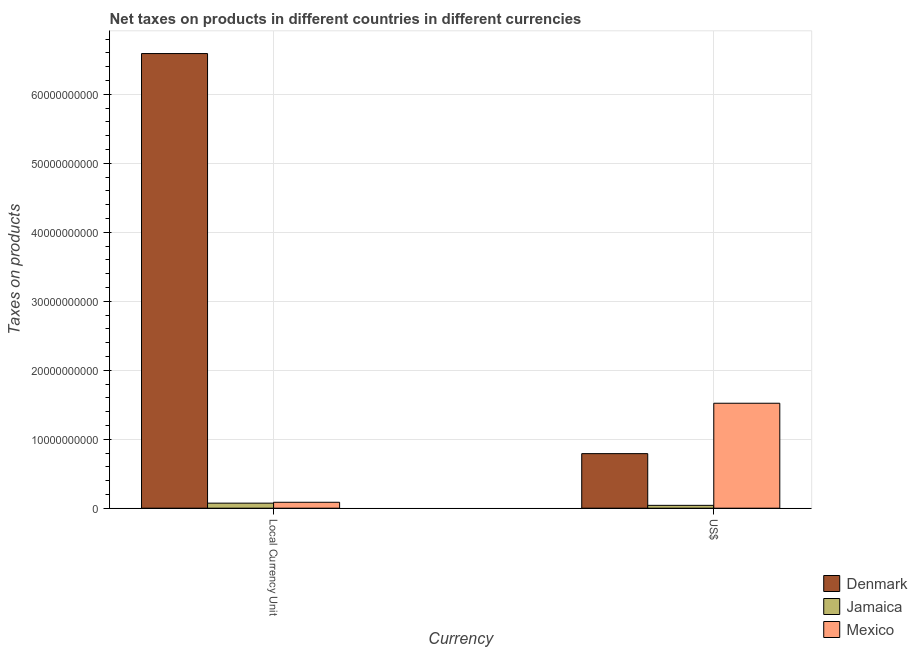How many groups of bars are there?
Your response must be concise. 2. Are the number of bars on each tick of the X-axis equal?
Make the answer very short. Yes. How many bars are there on the 1st tick from the right?
Make the answer very short. 3. What is the label of the 2nd group of bars from the left?
Provide a short and direct response. US$. What is the net taxes in constant 2005 us$ in Denmark?
Offer a terse response. 6.59e+1. Across all countries, what is the maximum net taxes in us$?
Your response must be concise. 1.52e+1. Across all countries, what is the minimum net taxes in us$?
Offer a terse response. 4.11e+08. In which country was the net taxes in constant 2005 us$ maximum?
Your answer should be very brief. Denmark. In which country was the net taxes in constant 2005 us$ minimum?
Give a very brief answer. Jamaica. What is the total net taxes in us$ in the graph?
Your answer should be compact. 2.35e+1. What is the difference between the net taxes in us$ in Denmark and that in Jamaica?
Keep it short and to the point. 7.50e+09. What is the difference between the net taxes in constant 2005 us$ in Mexico and the net taxes in us$ in Jamaica?
Provide a succinct answer. 4.47e+08. What is the average net taxes in us$ per country?
Your answer should be compact. 7.84e+09. What is the difference between the net taxes in constant 2005 us$ and net taxes in us$ in Mexico?
Provide a short and direct response. -1.44e+1. In how many countries, is the net taxes in constant 2005 us$ greater than 44000000000 units?
Your answer should be compact. 1. What is the ratio of the net taxes in us$ in Mexico to that in Denmark?
Give a very brief answer. 1.92. In how many countries, is the net taxes in constant 2005 us$ greater than the average net taxes in constant 2005 us$ taken over all countries?
Your answer should be compact. 1. How many bars are there?
Your answer should be very brief. 6. How many countries are there in the graph?
Give a very brief answer. 3. What is the difference between two consecutive major ticks on the Y-axis?
Your answer should be very brief. 1.00e+1. Are the values on the major ticks of Y-axis written in scientific E-notation?
Ensure brevity in your answer.  No. Does the graph contain grids?
Keep it short and to the point. Yes. How many legend labels are there?
Your response must be concise. 3. What is the title of the graph?
Offer a terse response. Net taxes on products in different countries in different currencies. Does "Peru" appear as one of the legend labels in the graph?
Your response must be concise. No. What is the label or title of the X-axis?
Give a very brief answer. Currency. What is the label or title of the Y-axis?
Make the answer very short. Taxes on products. What is the Taxes on products in Denmark in Local Currency Unit?
Offer a terse response. 6.59e+1. What is the Taxes on products in Jamaica in Local Currency Unit?
Ensure brevity in your answer.  7.32e+08. What is the Taxes on products in Mexico in Local Currency Unit?
Keep it short and to the point. 8.58e+08. What is the Taxes on products in Denmark in US$?
Make the answer very short. 7.91e+09. What is the Taxes on products in Jamaica in US$?
Provide a short and direct response. 4.11e+08. What is the Taxes on products in Mexico in US$?
Give a very brief answer. 1.52e+1. Across all Currency, what is the maximum Taxes on products of Denmark?
Give a very brief answer. 6.59e+1. Across all Currency, what is the maximum Taxes on products of Jamaica?
Give a very brief answer. 7.32e+08. Across all Currency, what is the maximum Taxes on products of Mexico?
Offer a very short reply. 1.52e+1. Across all Currency, what is the minimum Taxes on products in Denmark?
Ensure brevity in your answer.  7.91e+09. Across all Currency, what is the minimum Taxes on products of Jamaica?
Keep it short and to the point. 4.11e+08. Across all Currency, what is the minimum Taxes on products of Mexico?
Ensure brevity in your answer.  8.58e+08. What is the total Taxes on products in Denmark in the graph?
Give a very brief answer. 7.38e+1. What is the total Taxes on products of Jamaica in the graph?
Your response must be concise. 1.14e+09. What is the total Taxes on products of Mexico in the graph?
Give a very brief answer. 1.61e+1. What is the difference between the Taxes on products of Denmark in Local Currency Unit and that in US$?
Ensure brevity in your answer.  5.80e+1. What is the difference between the Taxes on products in Jamaica in Local Currency Unit and that in US$?
Your response must be concise. 3.21e+08. What is the difference between the Taxes on products of Mexico in Local Currency Unit and that in US$?
Offer a terse response. -1.44e+1. What is the difference between the Taxes on products of Denmark in Local Currency Unit and the Taxes on products of Jamaica in US$?
Offer a terse response. 6.55e+1. What is the difference between the Taxes on products of Denmark in Local Currency Unit and the Taxes on products of Mexico in US$?
Provide a short and direct response. 5.07e+1. What is the difference between the Taxes on products in Jamaica in Local Currency Unit and the Taxes on products in Mexico in US$?
Your answer should be very brief. -1.45e+1. What is the average Taxes on products of Denmark per Currency?
Give a very brief answer. 3.69e+1. What is the average Taxes on products of Jamaica per Currency?
Provide a short and direct response. 5.72e+08. What is the average Taxes on products in Mexico per Currency?
Your response must be concise. 8.04e+09. What is the difference between the Taxes on products of Denmark and Taxes on products of Jamaica in Local Currency Unit?
Offer a terse response. 6.52e+1. What is the difference between the Taxes on products of Denmark and Taxes on products of Mexico in Local Currency Unit?
Offer a very short reply. 6.50e+1. What is the difference between the Taxes on products of Jamaica and Taxes on products of Mexico in Local Currency Unit?
Provide a short and direct response. -1.26e+08. What is the difference between the Taxes on products of Denmark and Taxes on products of Jamaica in US$?
Keep it short and to the point. 7.50e+09. What is the difference between the Taxes on products in Denmark and Taxes on products in Mexico in US$?
Provide a short and direct response. -7.30e+09. What is the difference between the Taxes on products of Jamaica and Taxes on products of Mexico in US$?
Ensure brevity in your answer.  -1.48e+1. What is the ratio of the Taxes on products in Denmark in Local Currency Unit to that in US$?
Your answer should be compact. 8.33. What is the ratio of the Taxes on products in Jamaica in Local Currency Unit to that in US$?
Offer a terse response. 1.78. What is the ratio of the Taxes on products of Mexico in Local Currency Unit to that in US$?
Offer a very short reply. 0.06. What is the difference between the highest and the second highest Taxes on products of Denmark?
Your response must be concise. 5.80e+1. What is the difference between the highest and the second highest Taxes on products of Jamaica?
Make the answer very short. 3.21e+08. What is the difference between the highest and the second highest Taxes on products of Mexico?
Make the answer very short. 1.44e+1. What is the difference between the highest and the lowest Taxes on products of Denmark?
Provide a short and direct response. 5.80e+1. What is the difference between the highest and the lowest Taxes on products in Jamaica?
Your response must be concise. 3.21e+08. What is the difference between the highest and the lowest Taxes on products of Mexico?
Offer a very short reply. 1.44e+1. 